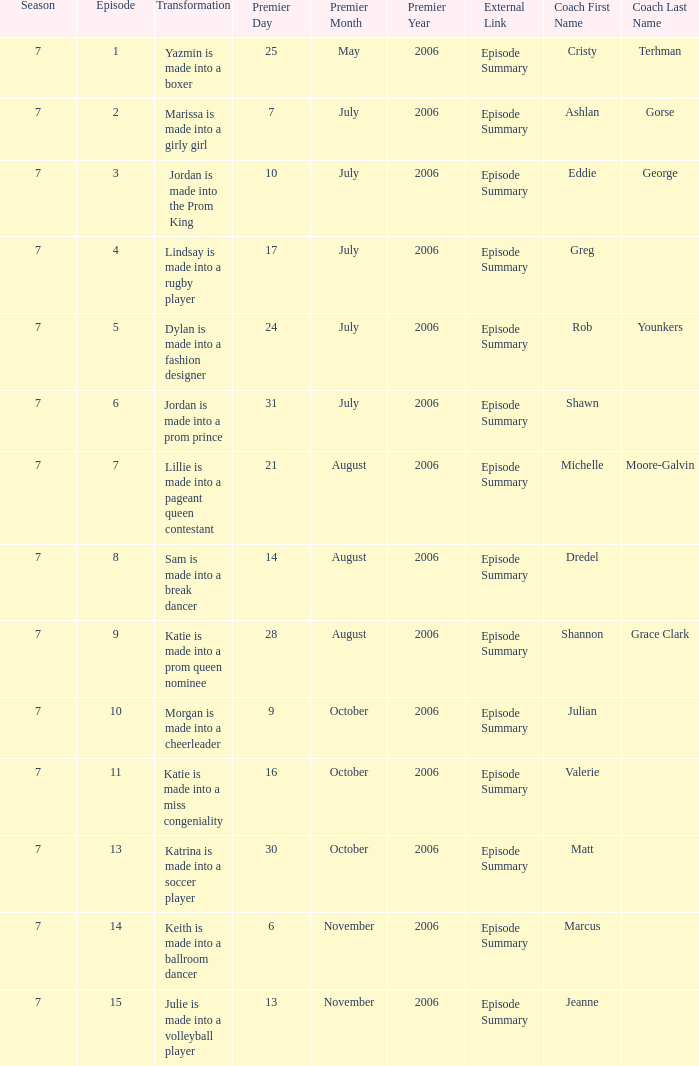How many episodes have a premier date of july 24, 2006 1.0. Could you parse the entire table? {'header': ['Season', 'Episode', 'Transformation', 'Premier Day', 'Premier Month', 'Premier Year', 'External Link', 'Coach First Name', 'Coach Last Name'], 'rows': [['7', '1', 'Yazmin is made into a boxer', '25', 'May', '2006', 'Episode Summary', 'Cristy', 'Terhman'], ['7', '2', 'Marissa is made into a girly girl', '7', 'July', '2006', 'Episode Summary', 'Ashlan', 'Gorse'], ['7', '3', 'Jordan is made into the Prom King', '10', 'July', '2006', 'Episode Summary', 'Eddie', 'George'], ['7', '4', 'Lindsay is made into a rugby player', '17', 'July', '2006', 'Episode Summary', 'Greg', ''], ['7', '5', 'Dylan is made into a fashion designer', '24', 'July', '2006', 'Episode Summary', 'Rob', 'Younkers'], ['7', '6', 'Jordan is made into a prom prince', '31', 'July', '2006', 'Episode Summary', 'Shawn', ''], ['7', '7', 'Lillie is made into a pageant queen contestant', '21', 'August', '2006', 'Episode Summary', 'Michelle', 'Moore-Galvin'], ['7', '8', 'Sam is made into a break dancer', '14', 'August', '2006', 'Episode Summary', 'Dredel', ''], ['7', '9', 'Katie is made into a prom queen nominee', '28', 'August', '2006', 'Episode Summary', 'Shannon', 'Grace Clark'], ['7', '10', 'Morgan is made into a cheerleader', '9', 'October', '2006', 'Episode Summary', 'Julian', ''], ['7', '11', 'Katie is made into a miss congeniality', '16', 'October', '2006', 'Episode Summary', 'Valerie', ''], ['7', '13', 'Katrina is made into a soccer player', '30', 'October', '2006', 'Episode Summary', 'Matt', ''], ['7', '14', 'Keith is made into a ballroom dancer', '6', 'November', '2006', 'Episode Summary', 'Marcus', ''], ['7', '15', 'Julie is made into a volleyball player', '13', 'November', '2006', 'Episode Summary', 'Jeanne', '']]} 